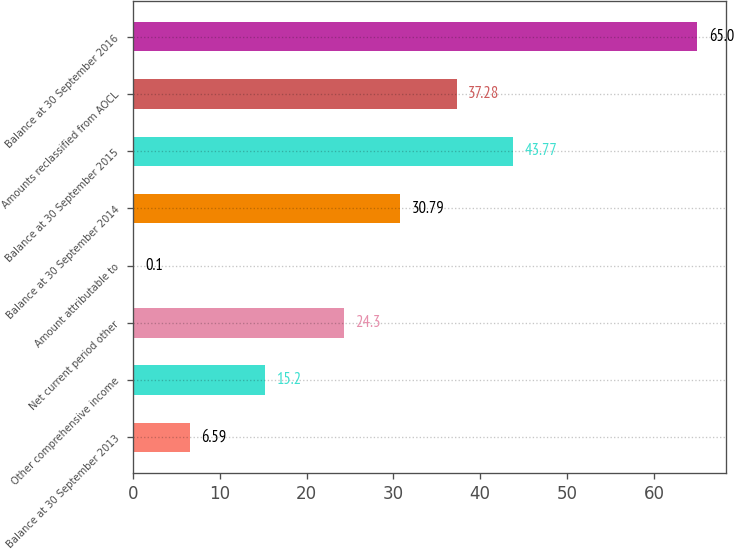<chart> <loc_0><loc_0><loc_500><loc_500><bar_chart><fcel>Balance at 30 September 2013<fcel>Other comprehensive income<fcel>Net current period other<fcel>Amount attributable to<fcel>Balance at 30 September 2014<fcel>Balance at 30 September 2015<fcel>Amounts reclassified from AOCL<fcel>Balance at 30 September 2016<nl><fcel>6.59<fcel>15.2<fcel>24.3<fcel>0.1<fcel>30.79<fcel>43.77<fcel>37.28<fcel>65<nl></chart> 